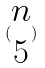<formula> <loc_0><loc_0><loc_500><loc_500>( \begin{matrix} n \\ 5 \end{matrix} )</formula> 